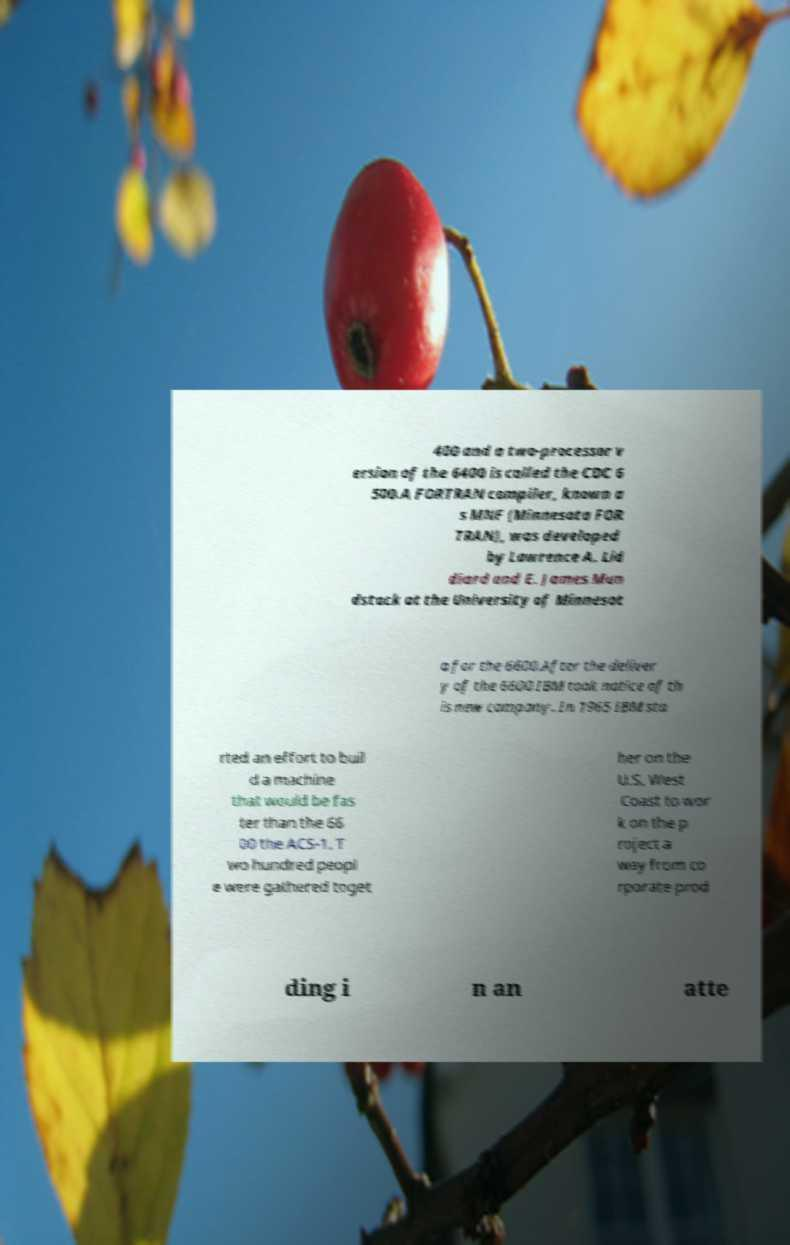Can you accurately transcribe the text from the provided image for me? 400 and a two-processor v ersion of the 6400 is called the CDC 6 500.A FORTRAN compiler, known a s MNF (Minnesota FOR TRAN), was developed by Lawrence A. Lid diard and E. James Mun dstock at the University of Minnesot a for the 6600.After the deliver y of the 6600 IBM took notice of th is new company. In 1965 IBM sta rted an effort to buil d a machine that would be fas ter than the 66 00 the ACS-1. T wo hundred peopl e were gathered toget her on the U.S. West Coast to wor k on the p roject a way from co rporate prod ding i n an atte 